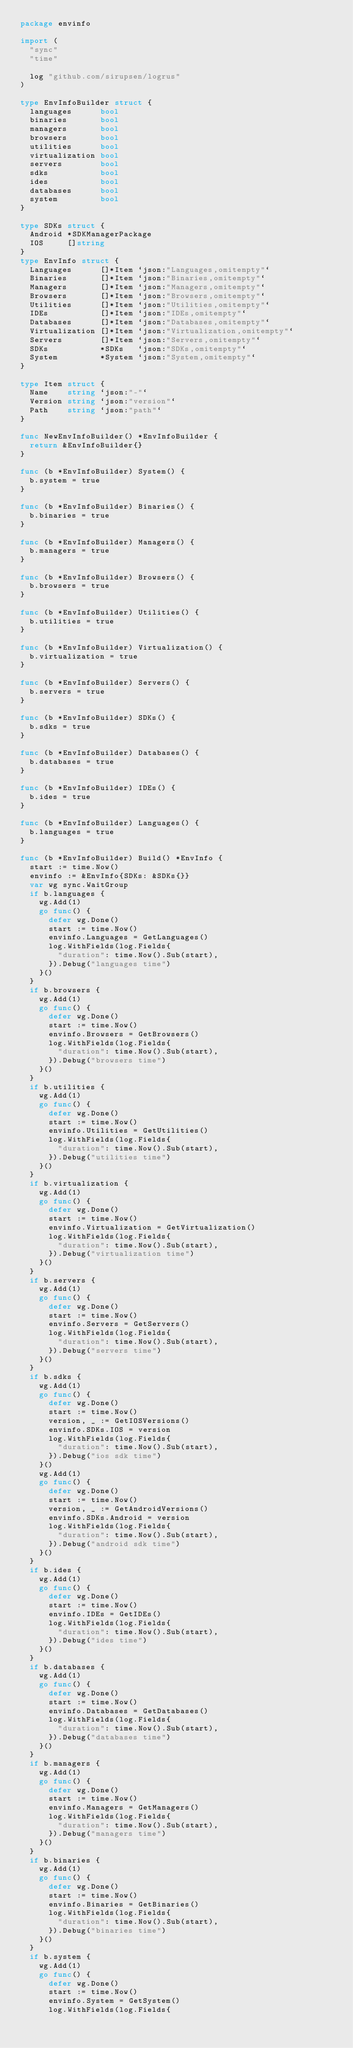Convert code to text. <code><loc_0><loc_0><loc_500><loc_500><_Go_>package envinfo

import (
	"sync"
	"time"

	log "github.com/sirupsen/logrus"
)

type EnvInfoBuilder struct {
	languages      bool
	binaries       bool
	managers       bool
	browsers       bool
	utilities      bool
	virtualization bool
	servers        bool
	sdks           bool
	ides           bool
	databases      bool
	system         bool
}

type SDKs struct {
	Android *SDKManagerPackage
	IOS     []string
}
type EnvInfo struct {
	Languages      []*Item `json:"Languages,omitempty"`
	Binaries       []*Item `json:"Binaries,omitempty"`
	Managers       []*Item `json:"Managers,omitempty"`
	Browsers       []*Item `json:"Browsers,omitempty"`
	Utilities      []*Item `json:"Utilities,omitempty"`
	IDEs           []*Item `json:"IDEs,omitempty"`
	Databases      []*Item `json:"Databases,omitempty"`
	Virtualization []*Item `json:"Virtualization,omitempty"`
	Servers        []*Item `json:"Servers,omitempty"`
	SDKs           *SDKs   `json:"SDKs,omitempty"`
	System         *System `json:"System,omitempty"`
}

type Item struct {
	Name    string `json:"-"`
	Version string `json:"version"`
	Path    string `json:"path"`
}

func NewEnvInfoBuilder() *EnvInfoBuilder {
	return &EnvInfoBuilder{}
}

func (b *EnvInfoBuilder) System() {
	b.system = true
}

func (b *EnvInfoBuilder) Binaries() {
	b.binaries = true
}

func (b *EnvInfoBuilder) Managers() {
	b.managers = true
}

func (b *EnvInfoBuilder) Browsers() {
	b.browsers = true
}

func (b *EnvInfoBuilder) Utilities() {
	b.utilities = true
}

func (b *EnvInfoBuilder) Virtualization() {
	b.virtualization = true
}

func (b *EnvInfoBuilder) Servers() {
	b.servers = true
}

func (b *EnvInfoBuilder) SDKs() {
	b.sdks = true
}

func (b *EnvInfoBuilder) Databases() {
	b.databases = true
}

func (b *EnvInfoBuilder) IDEs() {
	b.ides = true
}

func (b *EnvInfoBuilder) Languages() {
	b.languages = true
}

func (b *EnvInfoBuilder) Build() *EnvInfo {
	start := time.Now()
	envinfo := &EnvInfo{SDKs: &SDKs{}}
	var wg sync.WaitGroup
	if b.languages {
		wg.Add(1)
		go func() {
			defer wg.Done()
			start := time.Now()
			envinfo.Languages = GetLanguages()
			log.WithFields(log.Fields{
				"duration": time.Now().Sub(start),
			}).Debug("languages time")
		}()
	}
	if b.browsers {
		wg.Add(1)
		go func() {
			defer wg.Done()
			start := time.Now()
			envinfo.Browsers = GetBrowsers()
			log.WithFields(log.Fields{
				"duration": time.Now().Sub(start),
			}).Debug("browsers time")
		}()
	}
	if b.utilities {
		wg.Add(1)
		go func() {
			defer wg.Done()
			start := time.Now()
			envinfo.Utilities = GetUtilities()
			log.WithFields(log.Fields{
				"duration": time.Now().Sub(start),
			}).Debug("utilities time")
		}()
	}
	if b.virtualization {
		wg.Add(1)
		go func() {
			defer wg.Done()
			start := time.Now()
			envinfo.Virtualization = GetVirtualization()
			log.WithFields(log.Fields{
				"duration": time.Now().Sub(start),
			}).Debug("virtualization time")
		}()
	}
	if b.servers {
		wg.Add(1)
		go func() {
			defer wg.Done()
			start := time.Now()
			envinfo.Servers = GetServers()
			log.WithFields(log.Fields{
				"duration": time.Now().Sub(start),
			}).Debug("servers time")
		}()
	}
	if b.sdks {
		wg.Add(1)
		go func() {
			defer wg.Done()
			start := time.Now()
			version, _ := GetIOSVersions()
			envinfo.SDKs.IOS = version
			log.WithFields(log.Fields{
				"duration": time.Now().Sub(start),
			}).Debug("ios sdk time")
		}()
		wg.Add(1)
		go func() {
			defer wg.Done()
			start := time.Now()
			version, _ := GetAndroidVersions()
			envinfo.SDKs.Android = version
			log.WithFields(log.Fields{
				"duration": time.Now().Sub(start),
			}).Debug("android sdk time")
		}()
	}
	if b.ides {
		wg.Add(1)
		go func() {
			defer wg.Done()
			start := time.Now()
			envinfo.IDEs = GetIDEs()
			log.WithFields(log.Fields{
				"duration": time.Now().Sub(start),
			}).Debug("ides time")
		}()
	}
	if b.databases {
		wg.Add(1)
		go func() {
			defer wg.Done()
			start := time.Now()
			envinfo.Databases = GetDatabases()
			log.WithFields(log.Fields{
				"duration": time.Now().Sub(start),
			}).Debug("databases time")
		}()
	}
	if b.managers {
		wg.Add(1)
		go func() {
			defer wg.Done()
			start := time.Now()
			envinfo.Managers = GetManagers()
			log.WithFields(log.Fields{
				"duration": time.Now().Sub(start),
			}).Debug("managers time")
		}()
	}
	if b.binaries {
		wg.Add(1)
		go func() {
			defer wg.Done()
			start := time.Now()
			envinfo.Binaries = GetBinaries()
			log.WithFields(log.Fields{
				"duration": time.Now().Sub(start),
			}).Debug("binaries time")
		}()
	}
	if b.system {
		wg.Add(1)
		go func() {
			defer wg.Done()
			start := time.Now()
			envinfo.System = GetSystem()
			log.WithFields(log.Fields{</code> 